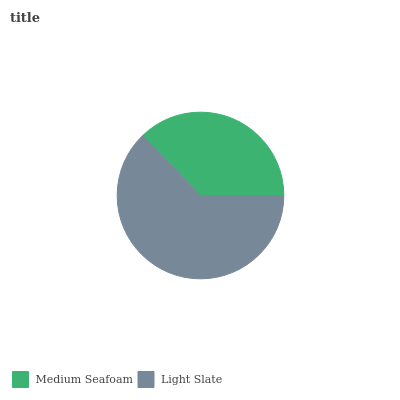Is Medium Seafoam the minimum?
Answer yes or no. Yes. Is Light Slate the maximum?
Answer yes or no. Yes. Is Light Slate the minimum?
Answer yes or no. No. Is Light Slate greater than Medium Seafoam?
Answer yes or no. Yes. Is Medium Seafoam less than Light Slate?
Answer yes or no. Yes. Is Medium Seafoam greater than Light Slate?
Answer yes or no. No. Is Light Slate less than Medium Seafoam?
Answer yes or no. No. Is Light Slate the high median?
Answer yes or no. Yes. Is Medium Seafoam the low median?
Answer yes or no. Yes. Is Medium Seafoam the high median?
Answer yes or no. No. Is Light Slate the low median?
Answer yes or no. No. 